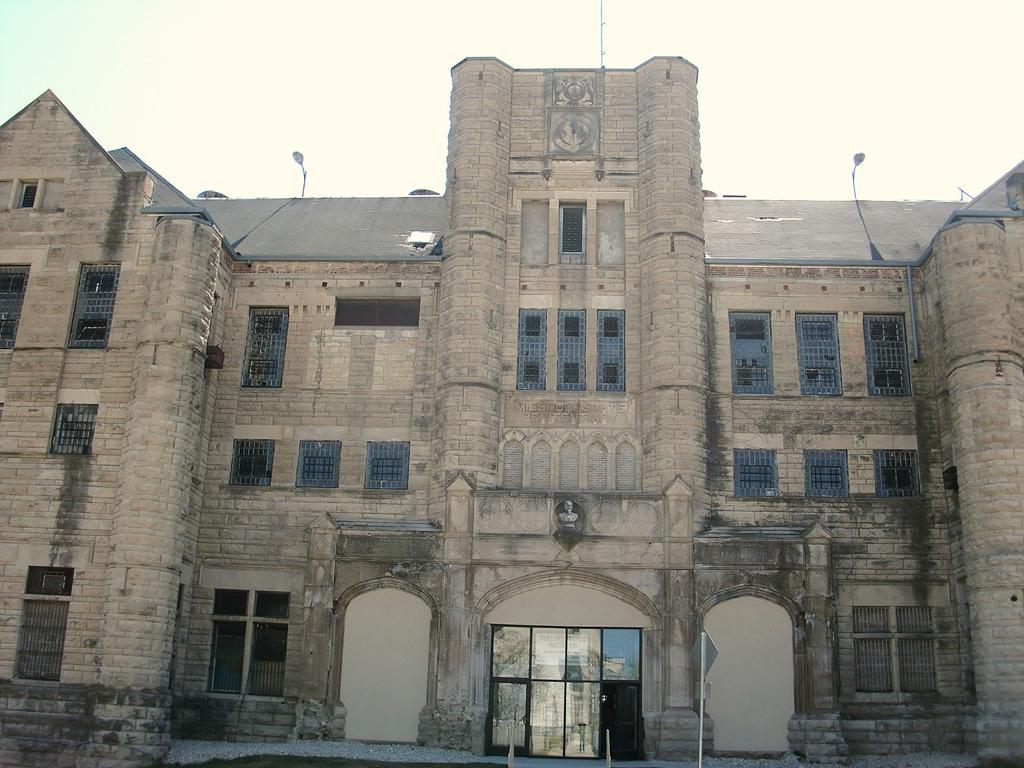In one or two sentences, can you explain what this image depicts? This is the building with the windows and doors. I think this is a sculpture. I can see the lights, which are at the top of the building. This looks like a pole. 